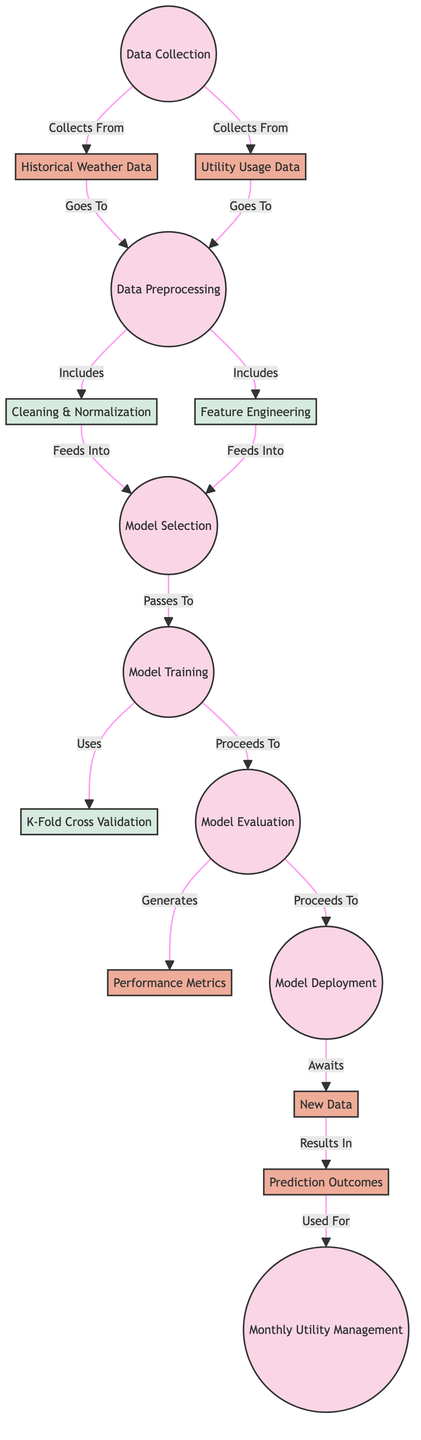What are the two data sources for the diagram? The diagram shows two data sources: "Historical Weather Data" and "Utility Usage Data." These sources are linked to the "Data Collection" process.
Answer: Historical Weather Data, Utility Usage Data What process follows data preprocessing? After data preprocessing, the next process is "Model Selection," which is indicated by the arrow leading from "Data Preprocessing" to "Model Selection."
Answer: Model Selection How many subprocesses are included in data preprocessing? The diagram lists two subprocesses within the "Data Preprocessing" process: "Cleaning & Normalization" and "Feature Engineering," resulting in a total of two subprocesses.
Answer: 2 What is the output of the model evaluation process? The output of the "Model Evaluation" process is "Performance Metrics," as indicated by the arrow showing the result of this process.
Answer: Performance Metrics What is the final outcome used for after the prediction outcomes are generated? The "Prediction Outcomes" are used for "Monthly Utility Management," as indicated by the arrow from "Prediction Outcomes" to "Monthly Utility Management."
Answer: Monthly Utility Management Which subprocess feeds into model selection? The subprocesses "Cleaning & Normalization" and "Feature Engineering" both feed into the "Model Selection" process, as indicated by the arrows pointing towards it from both subprocesses.
Answer: Cleaning & Normalization, Feature Engineering What type of cross-validation is utilized in model training? The diagram notes "K-Fold Cross Validation" as the method used within the "Model Training" process. This indicates that a specific form of cross-validation is employed during training.
Answer: K-Fold Cross Validation What action follows after model evaluation? The action that follows model evaluation is "Model Deployment," as indicated by the arrow leading from "Model Evaluation" to "Model Deployment."
Answer: Model Deployment 